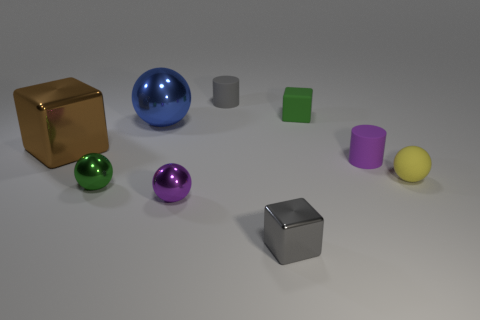There is a green ball that is the same size as the gray metallic cube; what is its material?
Your answer should be compact. Metal. What number of objects are either small gray things that are behind the purple shiny ball or tiny things that are to the right of the green ball?
Offer a very short reply. 6. There is a brown cube that is the same material as the green sphere; what is its size?
Provide a short and direct response. Large. How many rubber objects are either gray things or tiny yellow objects?
Make the answer very short. 2. How big is the purple ball?
Offer a terse response. Small. Do the green rubber thing and the purple cylinder have the same size?
Your answer should be compact. Yes. There is a purple thing to the right of the gray block; what is its material?
Offer a very short reply. Rubber. What material is the yellow object that is the same shape as the blue metallic object?
Your response must be concise. Rubber. Is there a matte cylinder that is left of the blue metallic ball on the left side of the small yellow matte object?
Your response must be concise. No. Do the tiny yellow object and the green shiny thing have the same shape?
Your answer should be very brief. Yes. 